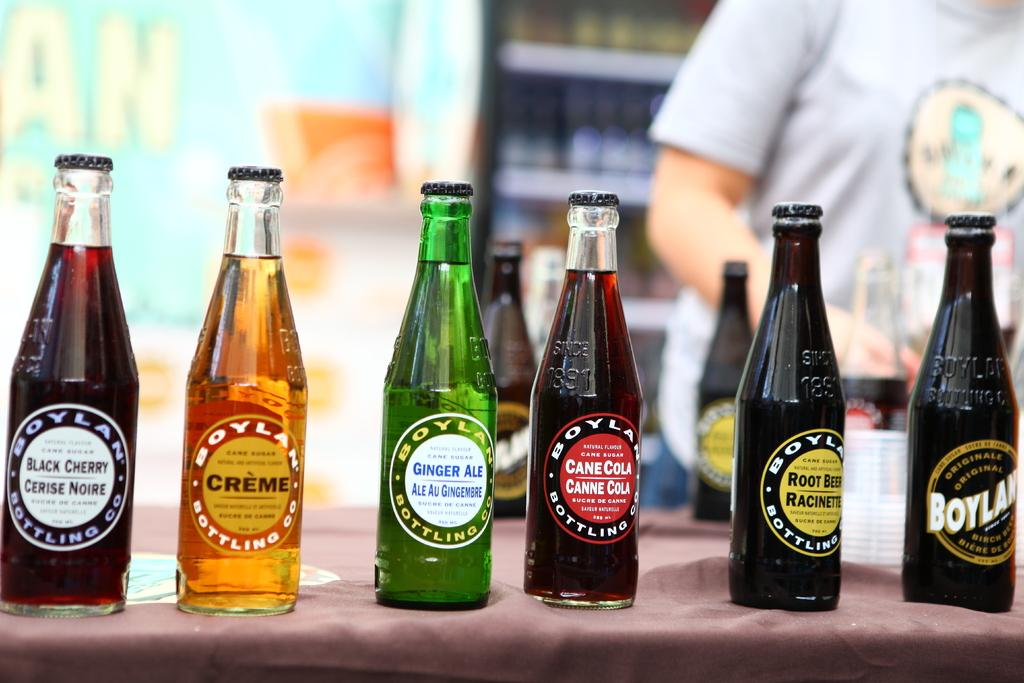Provide a one-sentence caption for the provided image. Various bottles of soda such as ginger ale and black cherry. 